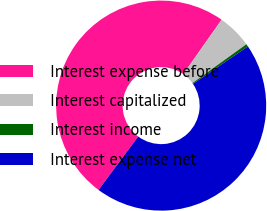<chart> <loc_0><loc_0><loc_500><loc_500><pie_chart><fcel>Interest expense before<fcel>Interest capitalized<fcel>Interest income<fcel>Interest expense net<nl><fcel>49.59%<fcel>5.31%<fcel>0.41%<fcel>44.69%<nl></chart> 